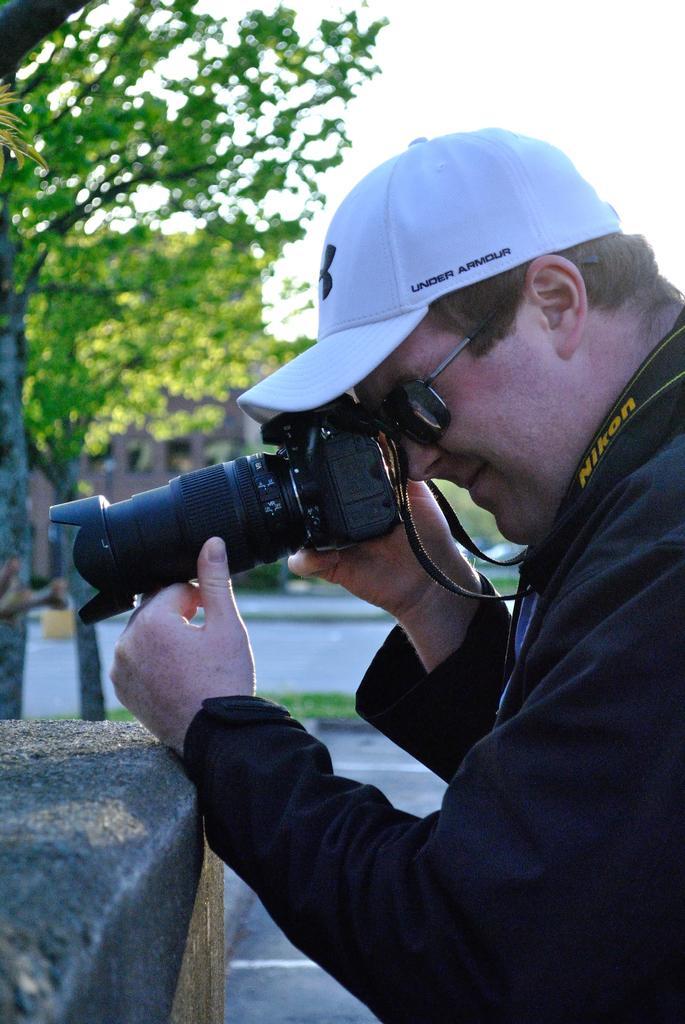Please provide a concise description of this image. In this image I see a man who is wearing a cap and shades and he is holding a camera. In the background I can see the trees, path and the sky. 